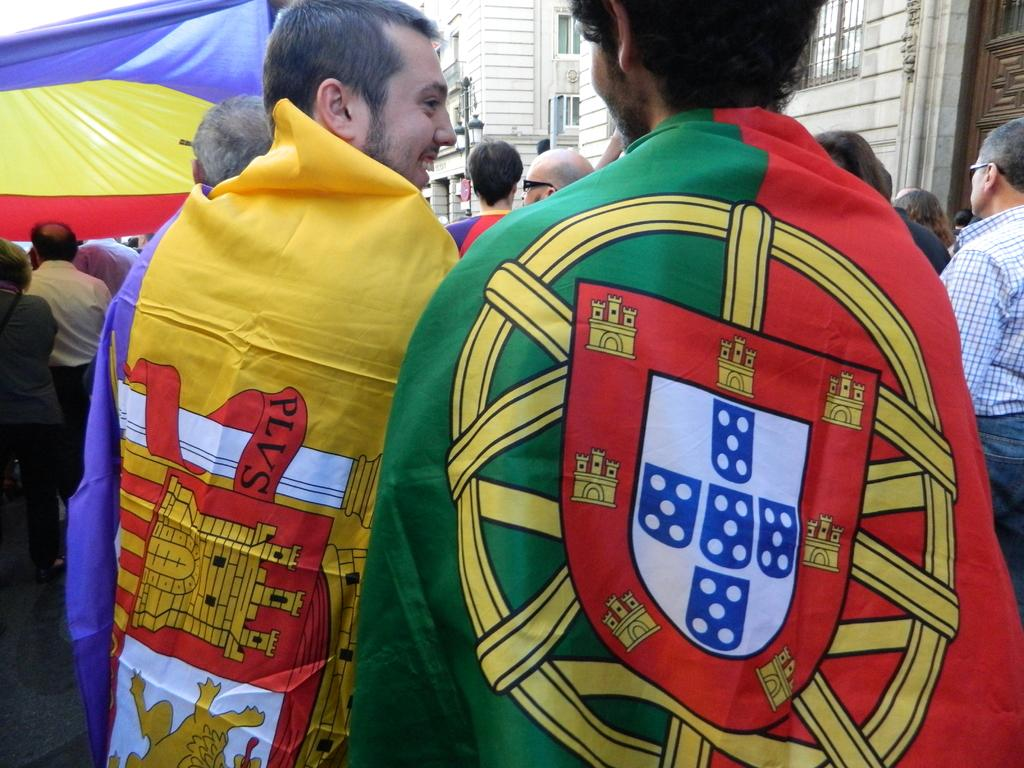Who or what can be seen in the image? There are people in the image. What can be seen in the distance behind the people? There are buildings in the background of the image. What subject are the people teaching in the image? There is no indication in the image that the people are teaching, so it cannot be determined from the picture. 